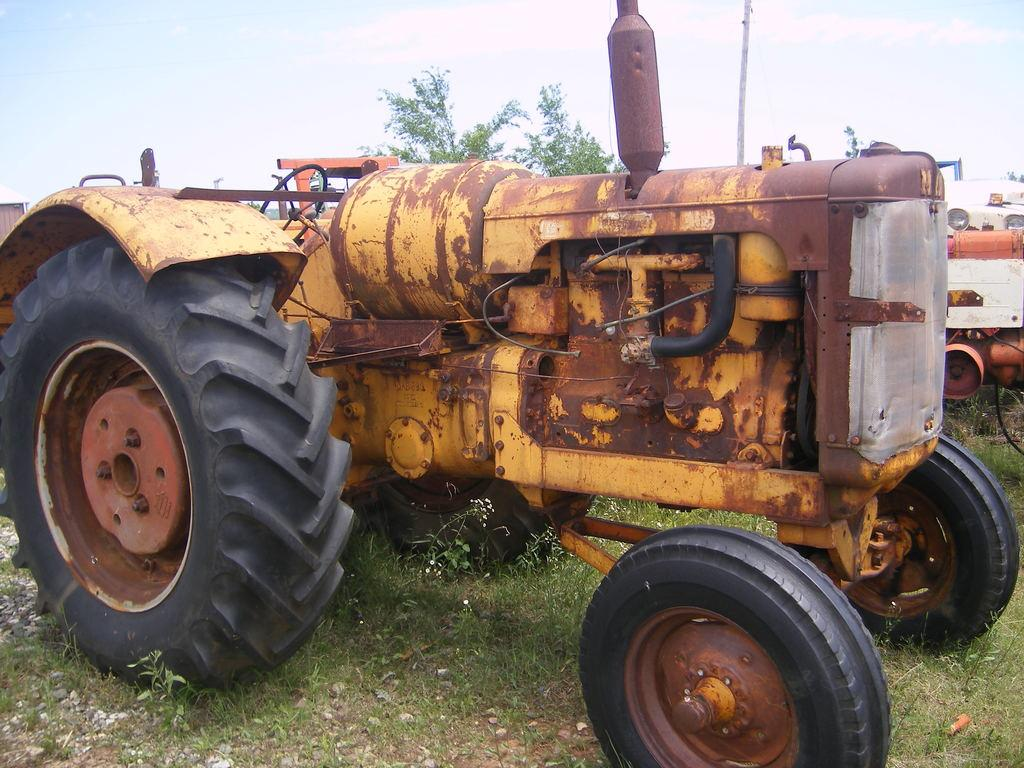What types of vehicles are in the image? There are vehicles in the image, but the specific types are not mentioned. What is at the bottom of the image? There is grass at the bottom of the image. What can be seen in the background of the image? There are trees and sky visible in the background of the image. What object is present in the image that is not a vehicle or part of the natural environment? There is a pole in the image. Can you see a donkey holding a pencil in the image? No, there is no donkey or pencil present in the image. 